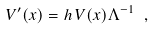Convert formula to latex. <formula><loc_0><loc_0><loc_500><loc_500>V ^ { \prime } ( x ) = h \, V ( x ) \Lambda ^ { - 1 } \ ,</formula> 